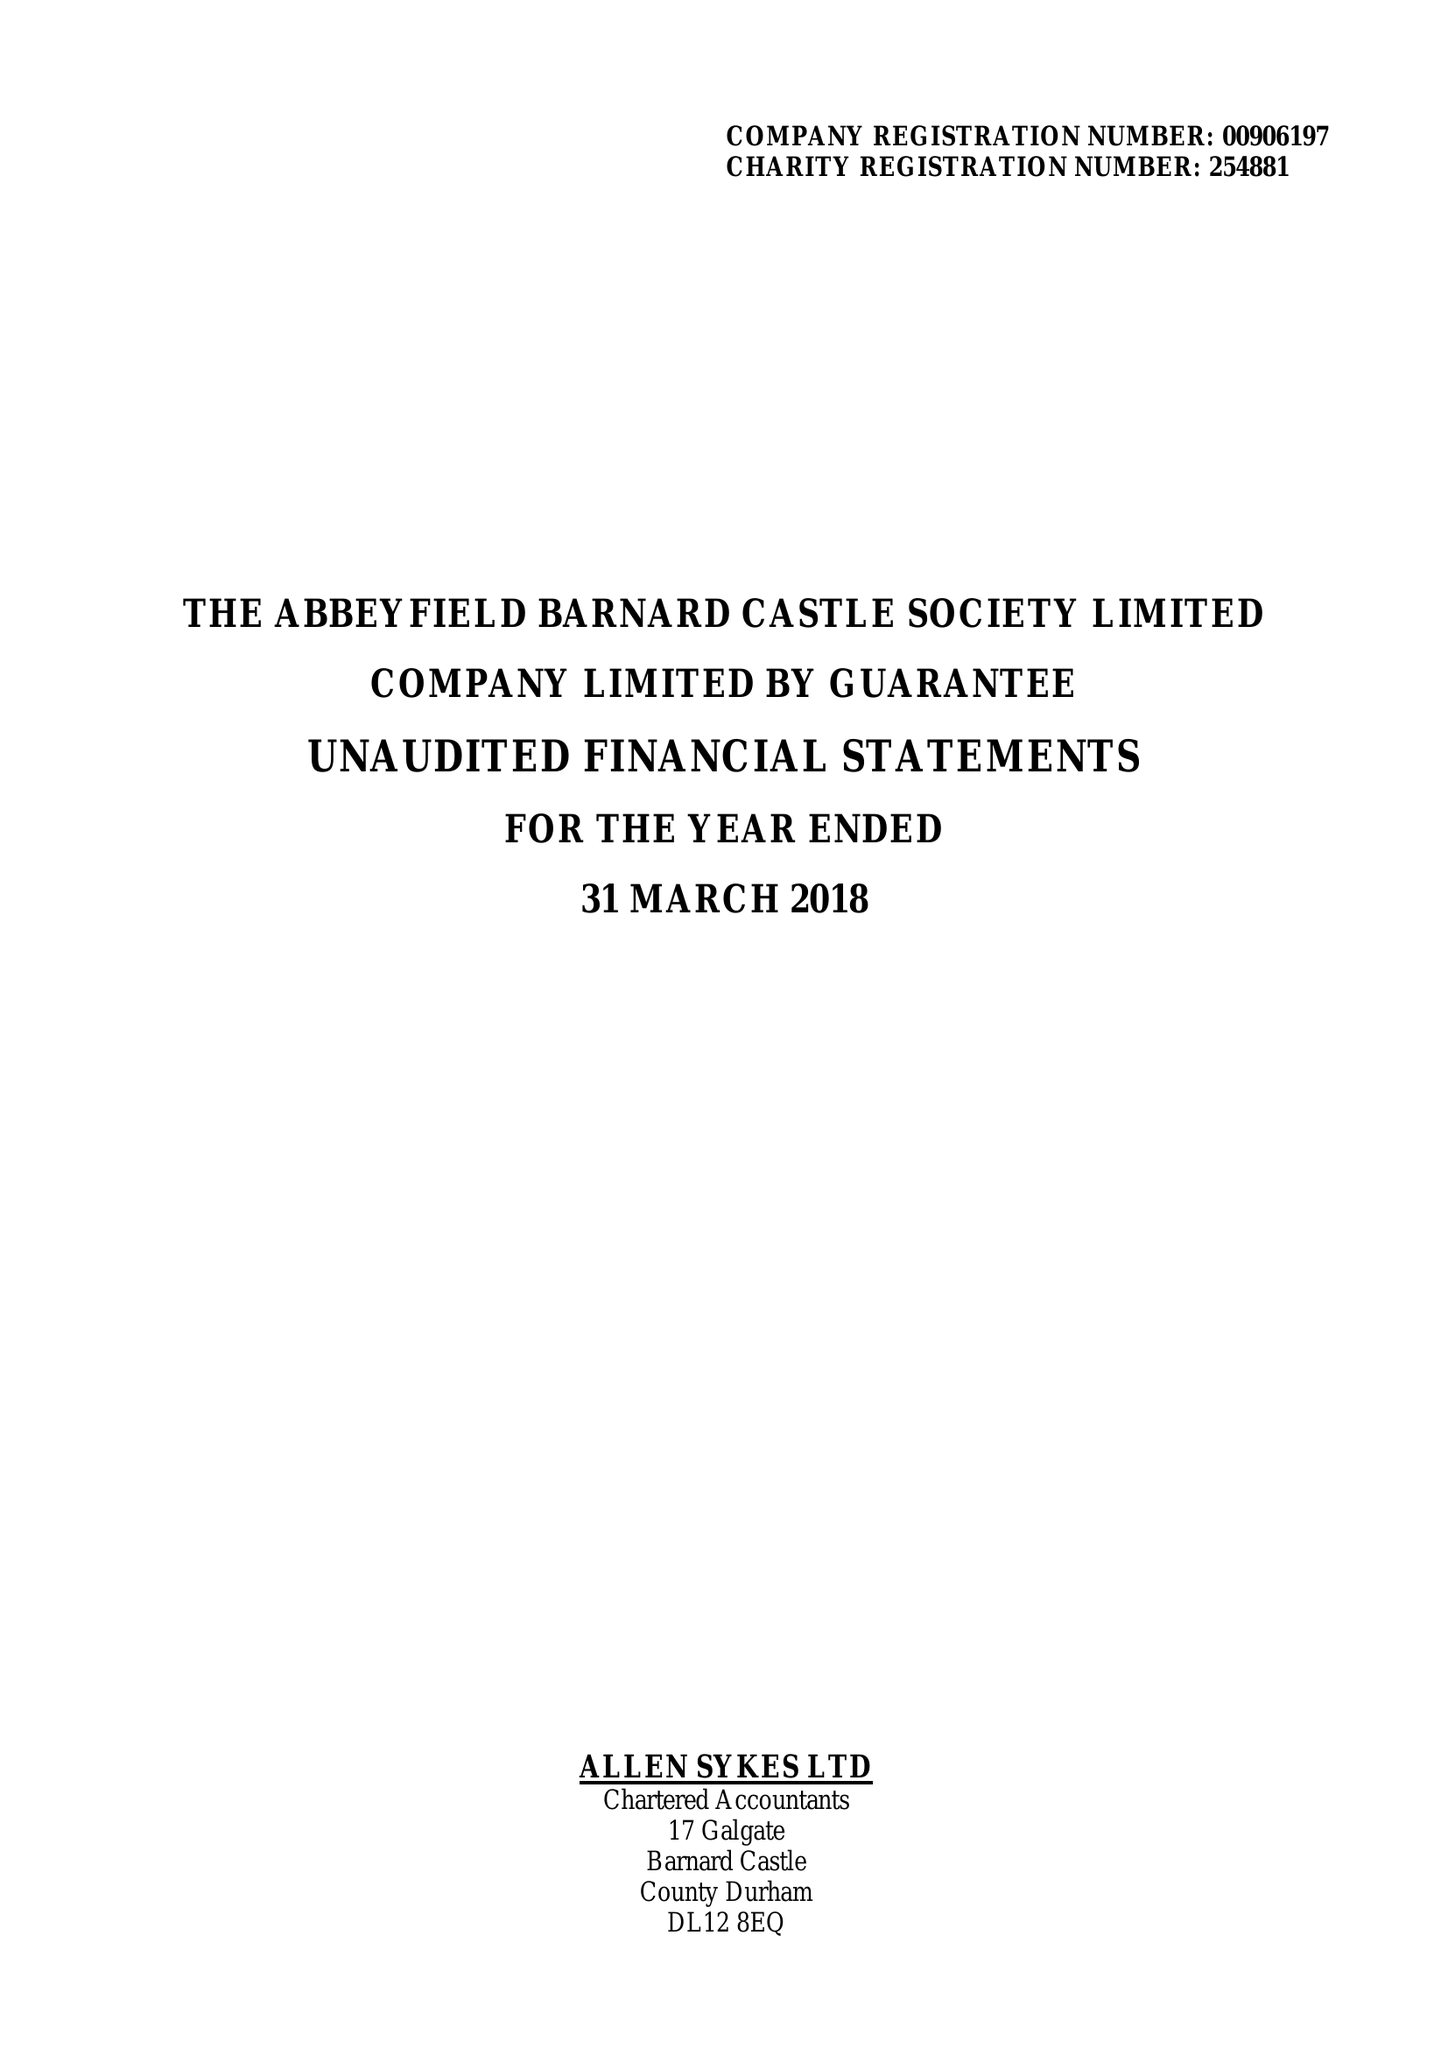What is the value for the income_annually_in_british_pounds?
Answer the question using a single word or phrase. 141923.00 